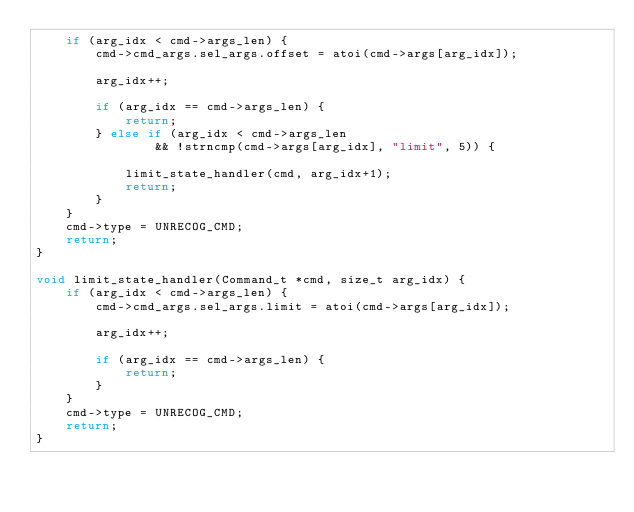Convert code to text. <code><loc_0><loc_0><loc_500><loc_500><_C_>    if (arg_idx < cmd->args_len) {
        cmd->cmd_args.sel_args.offset = atoi(cmd->args[arg_idx]);

        arg_idx++;

        if (arg_idx == cmd->args_len) {
            return;
        } else if (arg_idx < cmd->args_len
                && !strncmp(cmd->args[arg_idx], "limit", 5)) {

            limit_state_handler(cmd, arg_idx+1);
            return;
        }
    }
    cmd->type = UNRECOG_CMD;
    return;
}

void limit_state_handler(Command_t *cmd, size_t arg_idx) {
    if (arg_idx < cmd->args_len) {
        cmd->cmd_args.sel_args.limit = atoi(cmd->args[arg_idx]);

        arg_idx++;

        if (arg_idx == cmd->args_len) {
            return;
        }
    }
    cmd->type = UNRECOG_CMD;
    return;
}
</code> 